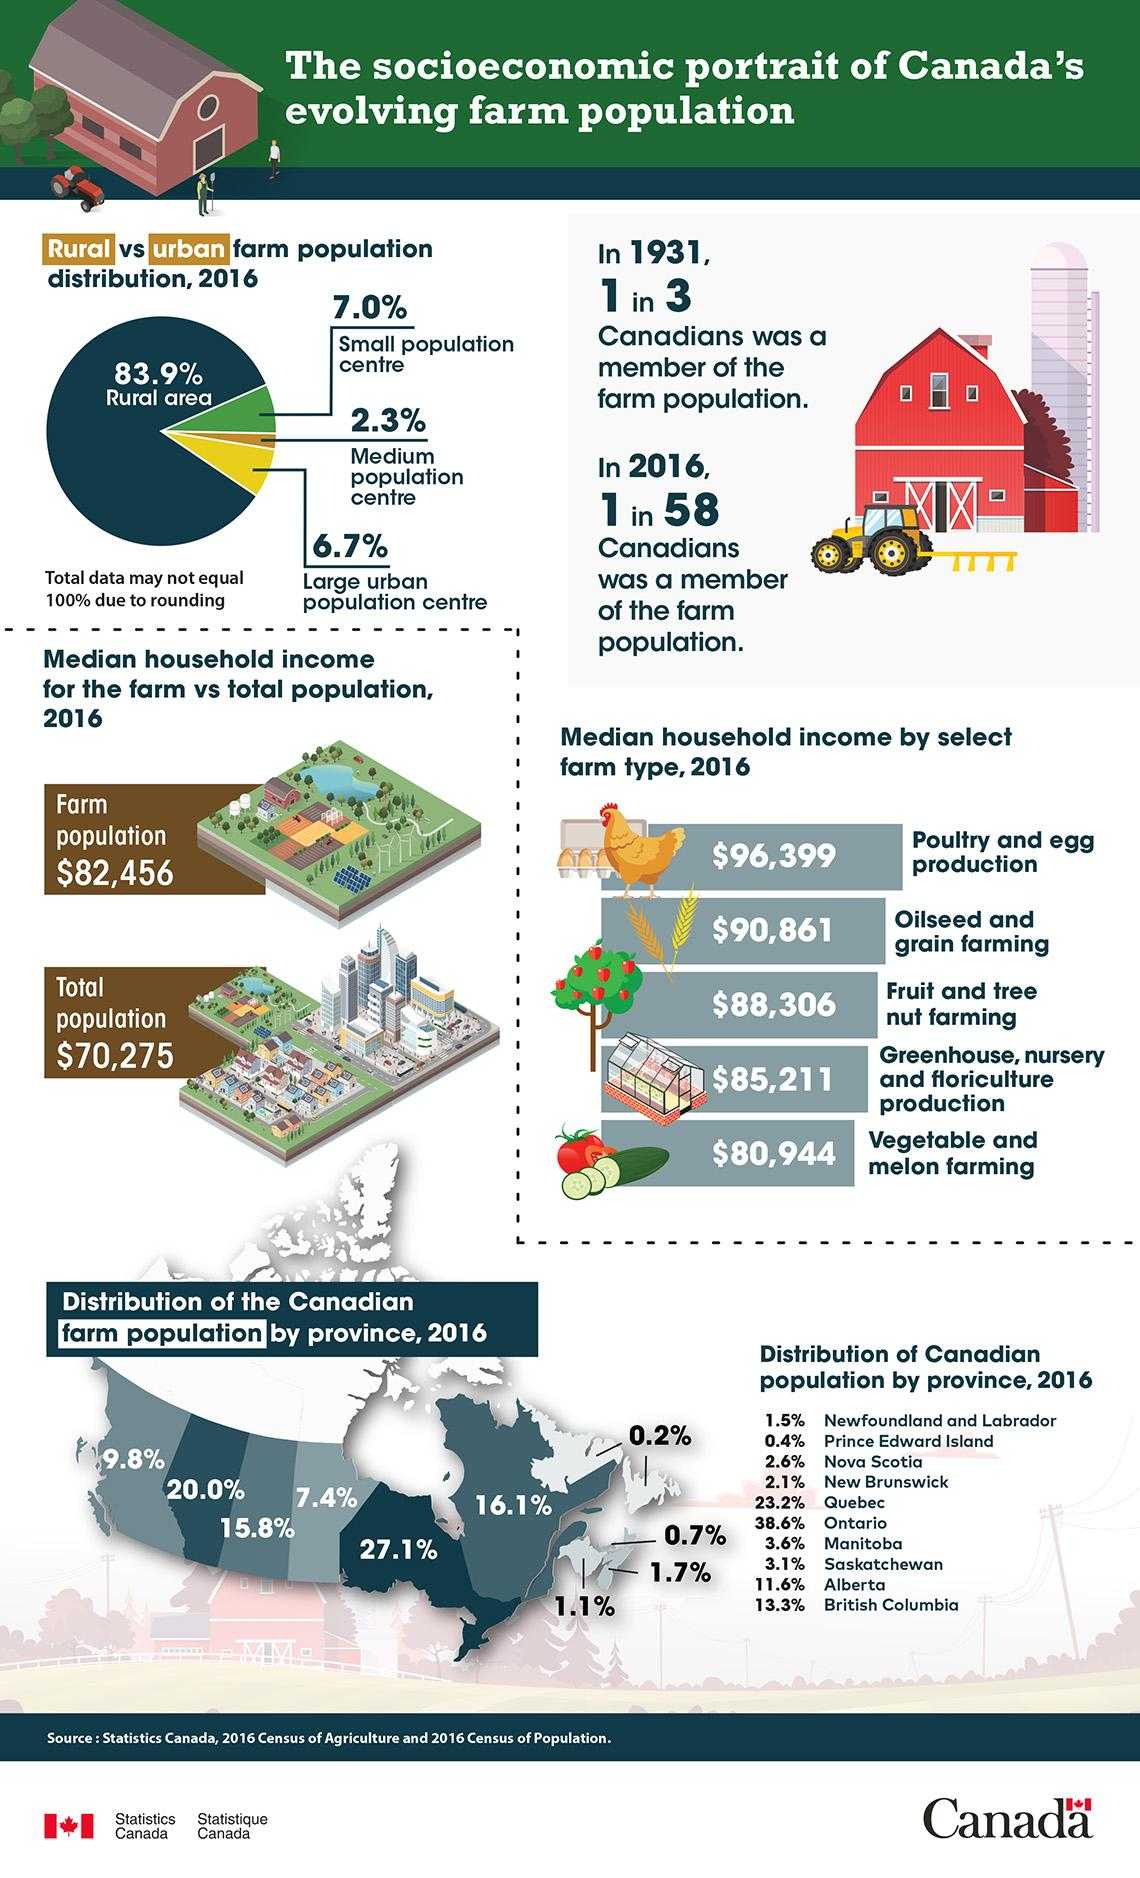List a handful of essential elements in this visual. During the year 1931, approximately one-third of the population was involved in farming. 